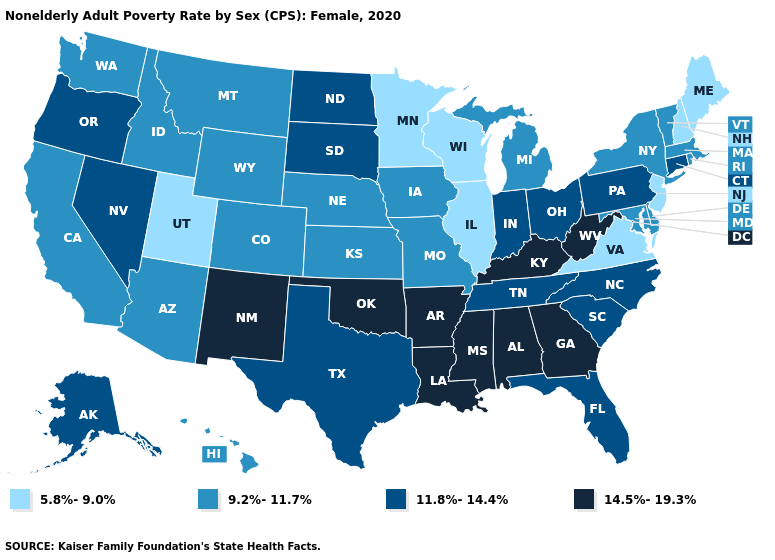What is the value of New Jersey?
Be succinct. 5.8%-9.0%. What is the value of Iowa?
Write a very short answer. 9.2%-11.7%. Among the states that border Wyoming , does Utah have the lowest value?
Short answer required. Yes. What is the value of Maryland?
Answer briefly. 9.2%-11.7%. What is the lowest value in the USA?
Concise answer only. 5.8%-9.0%. What is the lowest value in the Northeast?
Give a very brief answer. 5.8%-9.0%. Which states have the lowest value in the South?
Be succinct. Virginia. Does Nebraska have a lower value than Maryland?
Quick response, please. No. Among the states that border Missouri , which have the highest value?
Write a very short answer. Arkansas, Kentucky, Oklahoma. Does Michigan have the highest value in the MidWest?
Quick response, please. No. Name the states that have a value in the range 11.8%-14.4%?
Short answer required. Alaska, Connecticut, Florida, Indiana, Nevada, North Carolina, North Dakota, Ohio, Oregon, Pennsylvania, South Carolina, South Dakota, Tennessee, Texas. What is the value of Ohio?
Answer briefly. 11.8%-14.4%. What is the lowest value in states that border South Carolina?
Be succinct. 11.8%-14.4%. Which states have the highest value in the USA?
Be succinct. Alabama, Arkansas, Georgia, Kentucky, Louisiana, Mississippi, New Mexico, Oklahoma, West Virginia. Among the states that border Connecticut , which have the highest value?
Answer briefly. Massachusetts, New York, Rhode Island. 